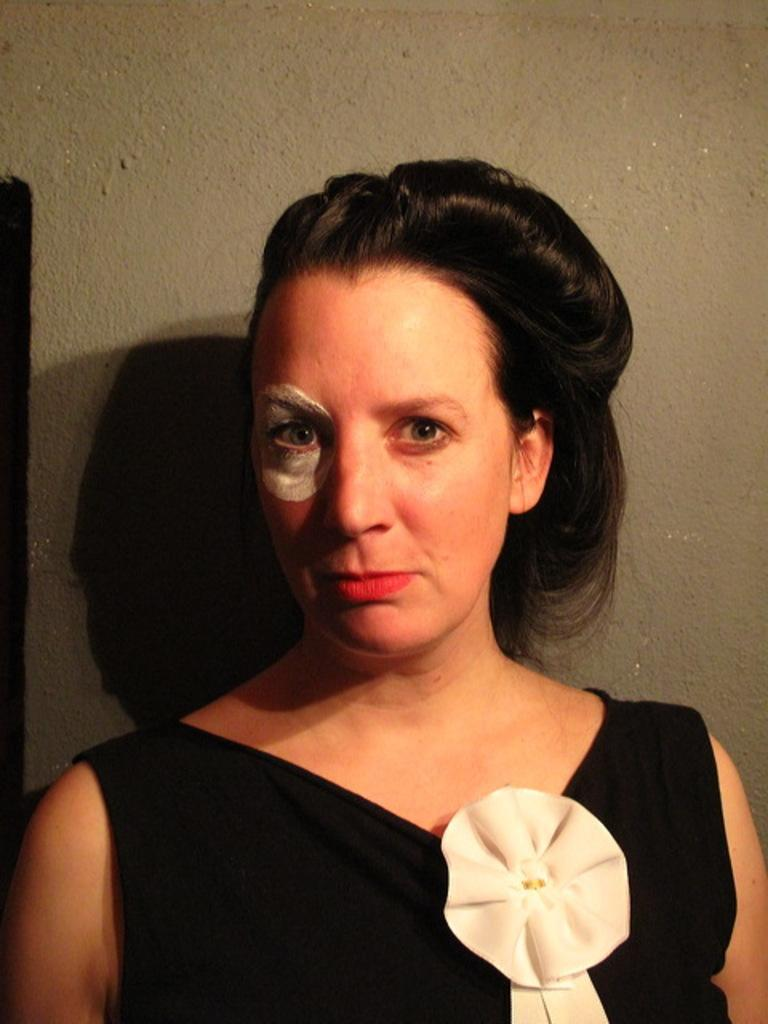Who is the main subject in the image? There is a woman in the image. What is the woman wearing? The woman is wearing a black dress. Can you describe any unique features of the woman's appearance? The woman has white paint on her eye. What type of waste can be seen in the woman's hand in the image? There is no waste present in the image; the woman is not holding anything in her hand. 